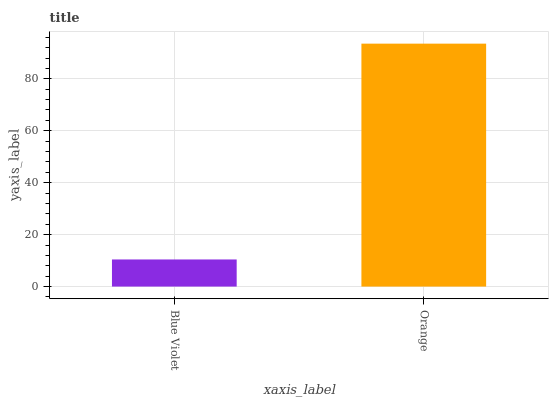Is Blue Violet the minimum?
Answer yes or no. Yes. Is Orange the maximum?
Answer yes or no. Yes. Is Orange the minimum?
Answer yes or no. No. Is Orange greater than Blue Violet?
Answer yes or no. Yes. Is Blue Violet less than Orange?
Answer yes or no. Yes. Is Blue Violet greater than Orange?
Answer yes or no. No. Is Orange less than Blue Violet?
Answer yes or no. No. Is Orange the high median?
Answer yes or no. Yes. Is Blue Violet the low median?
Answer yes or no. Yes. Is Blue Violet the high median?
Answer yes or no. No. Is Orange the low median?
Answer yes or no. No. 